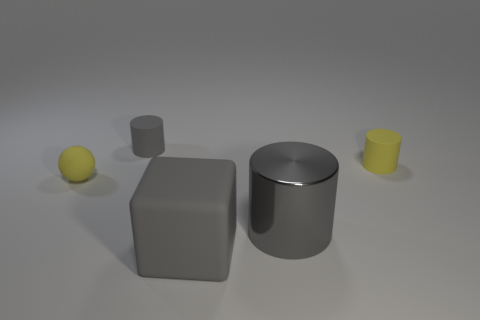Add 4 tiny yellow rubber spheres. How many objects exist? 9 Subtract 0 gray spheres. How many objects are left? 5 Subtract all cylinders. How many objects are left? 2 Subtract 1 cylinders. How many cylinders are left? 2 Subtract all gray spheres. Subtract all green cylinders. How many spheres are left? 1 Subtract all cyan spheres. How many blue cylinders are left? 0 Subtract all spheres. Subtract all tiny yellow matte objects. How many objects are left? 2 Add 3 gray objects. How many gray objects are left? 6 Add 3 small yellow matte balls. How many small yellow matte balls exist? 4 Subtract all yellow cylinders. How many cylinders are left? 2 